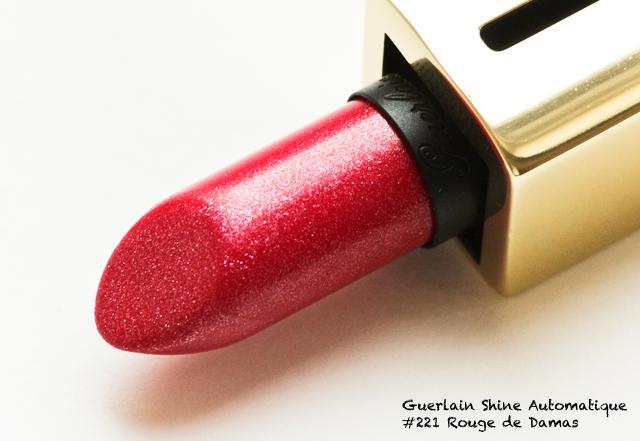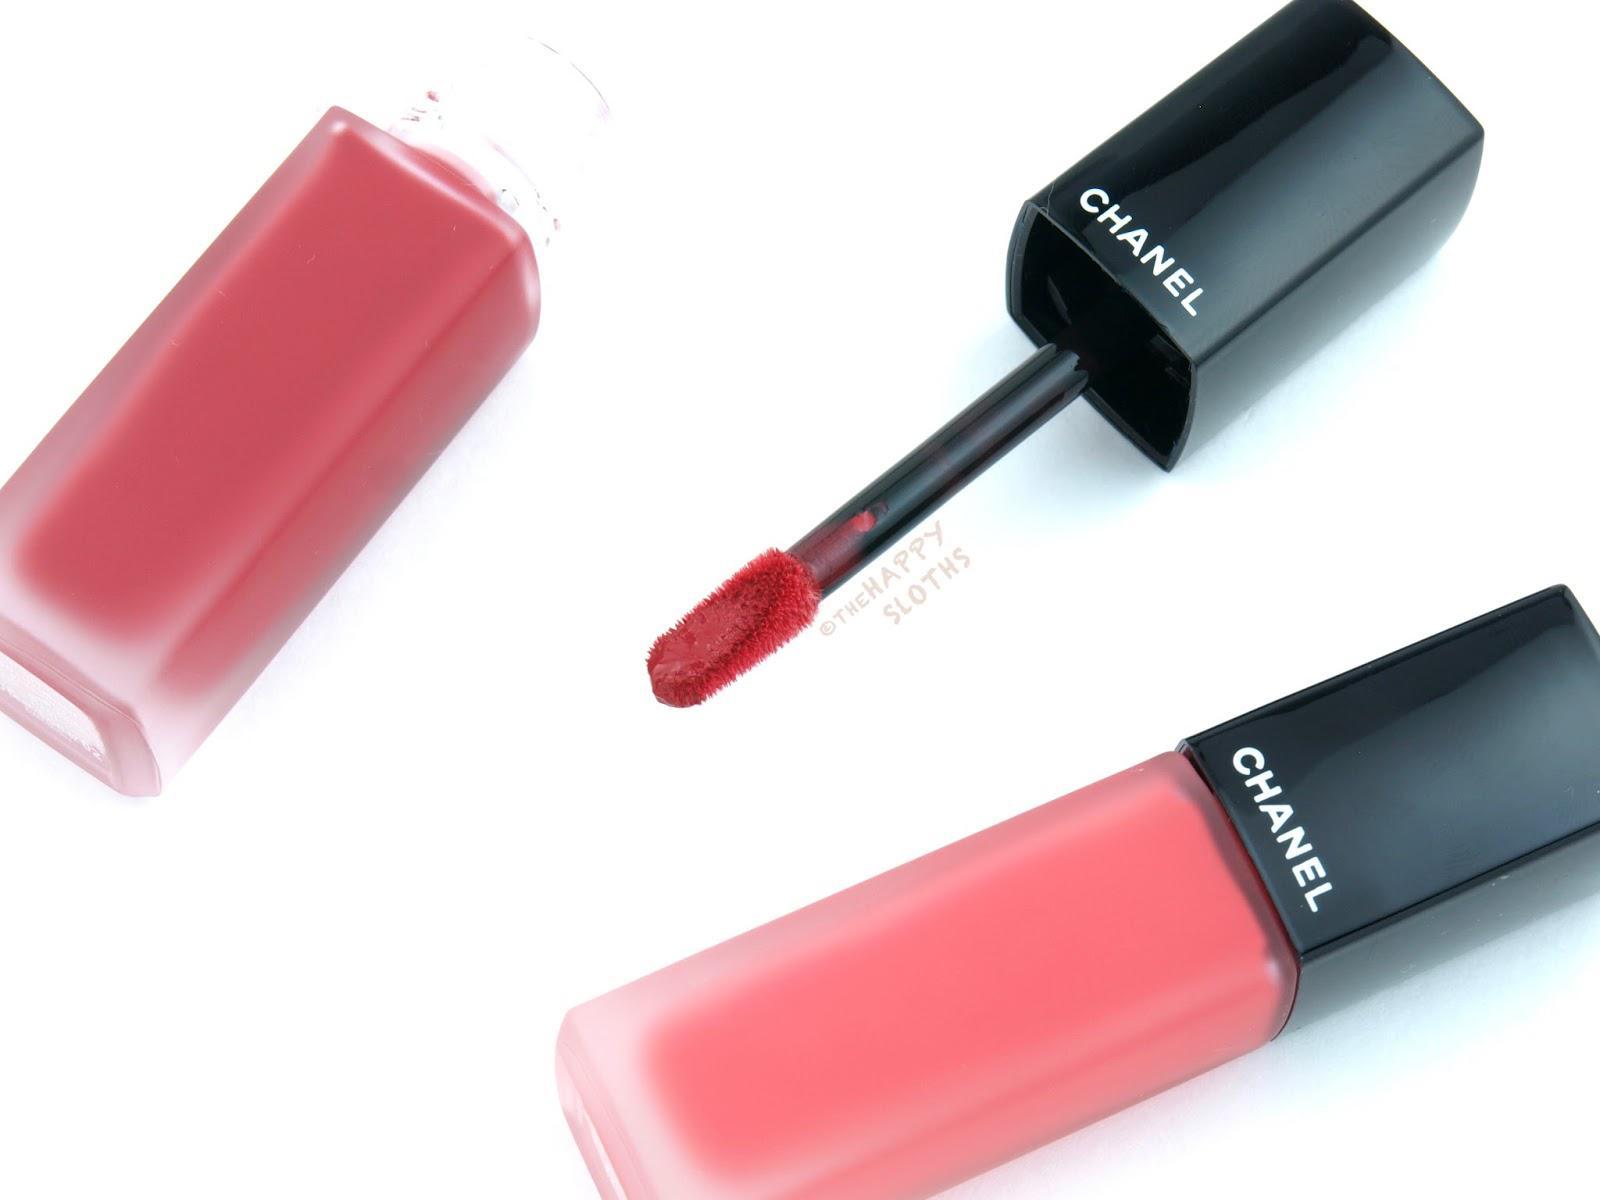The first image is the image on the left, the second image is the image on the right. Examine the images to the left and right. Is the description "There is at least one lipgloss." accurate? Answer yes or no. Yes. 